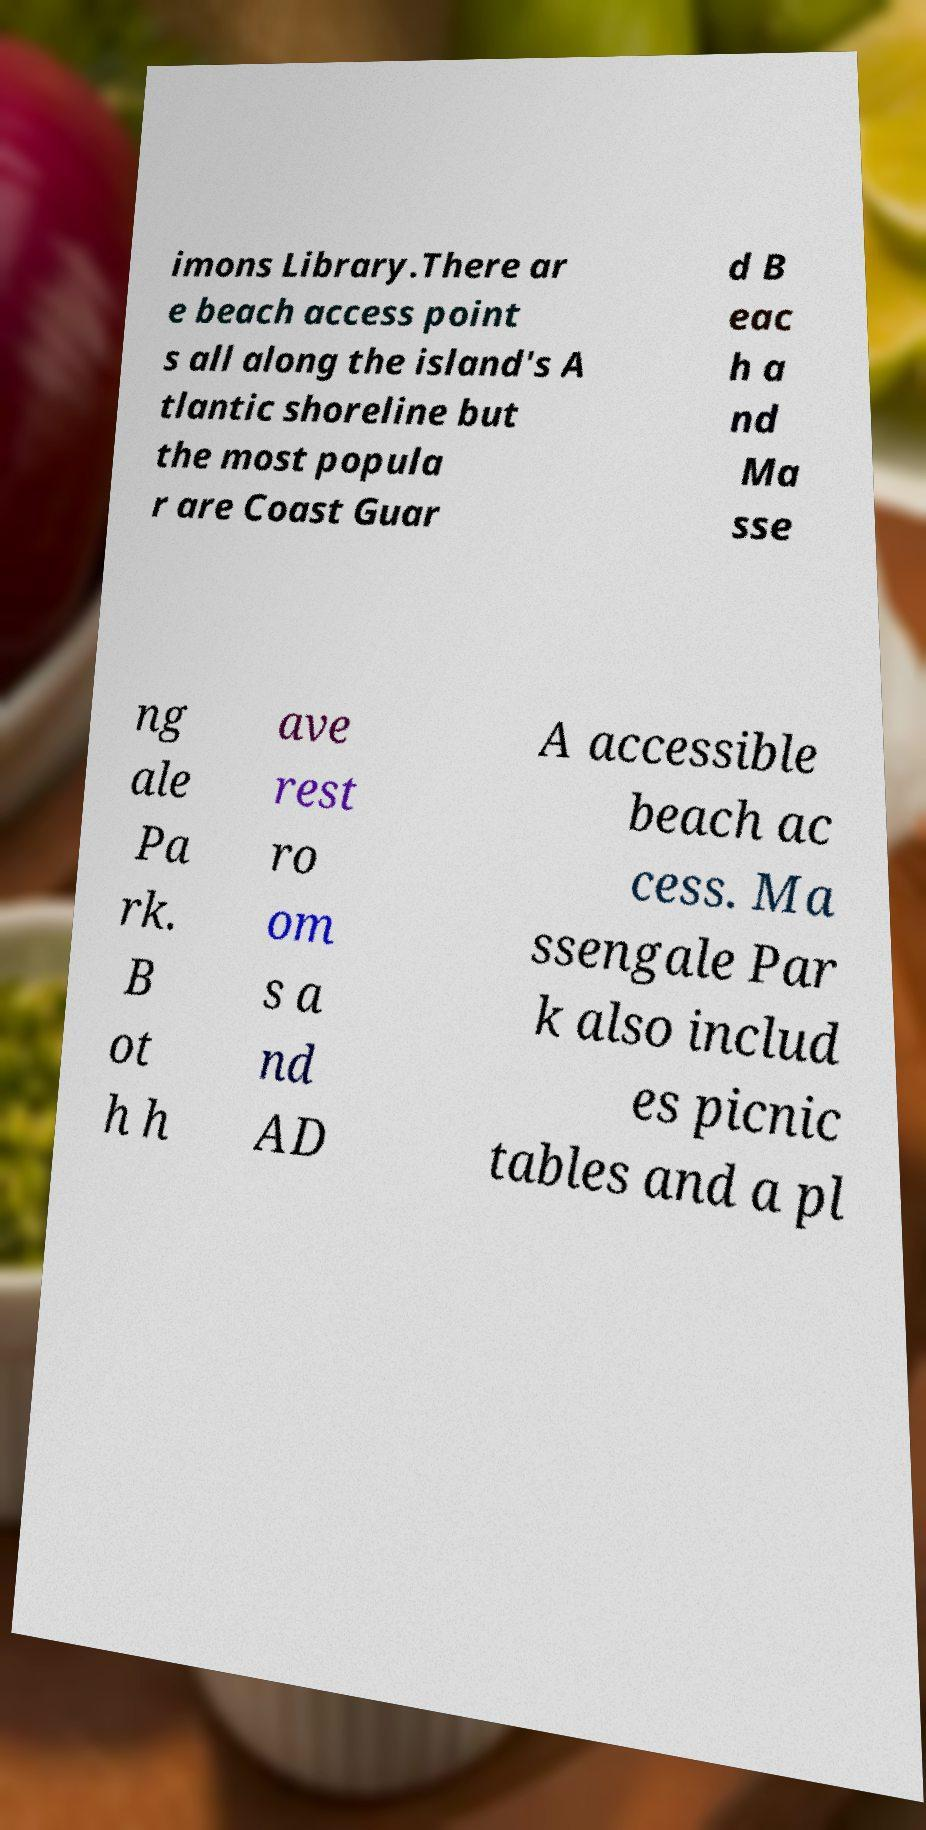Could you extract and type out the text from this image? imons Library.There ar e beach access point s all along the island's A tlantic shoreline but the most popula r are Coast Guar d B eac h a nd Ma sse ng ale Pa rk. B ot h h ave rest ro om s a nd AD A accessible beach ac cess. Ma ssengale Par k also includ es picnic tables and a pl 